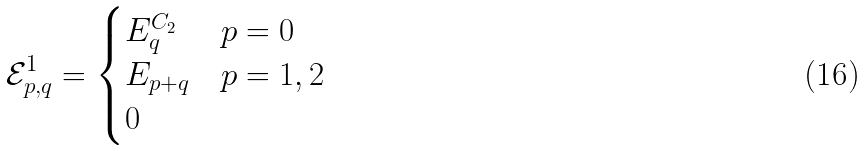Convert formula to latex. <formula><loc_0><loc_0><loc_500><loc_500>\mathcal { E } ^ { 1 } _ { p , q } = \begin{cases} E ^ { C _ { 2 } } _ { q } & p = 0 \\ E _ { p + q } & p = 1 , 2 \\ 0 & \end{cases}</formula> 